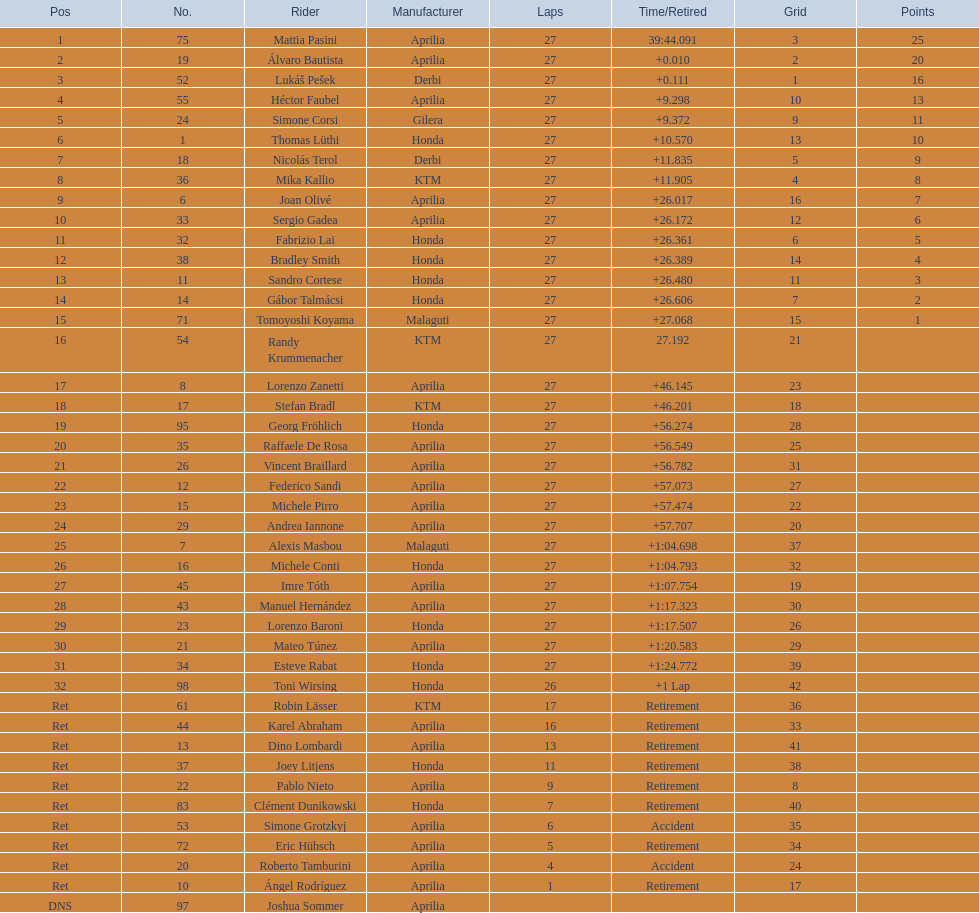Out of all the people who have points, who has the least? Tomoyoshi Koyama. 